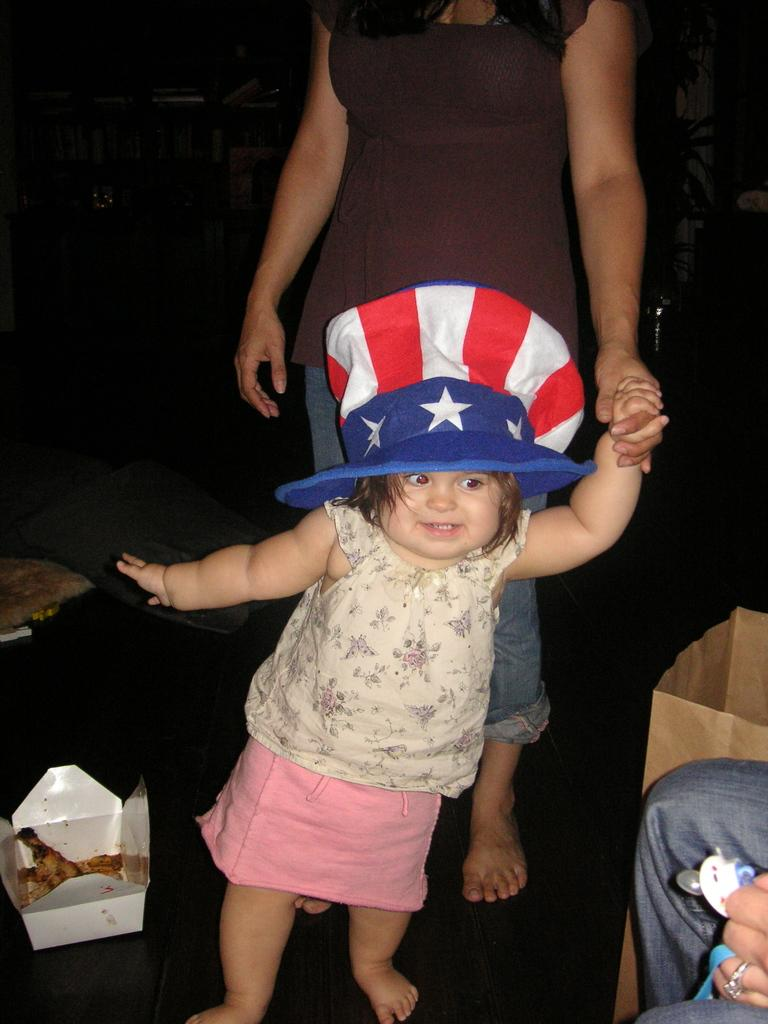Who is present in the image? There is a person and a kid in the image. What are the person and the kid doing in the image? Both the person and the kid are standing on the floor. Can you describe the person's attire? The person is wearing a cap. What other object can be seen in the image? There is a box in the image. How would you describe the lighting in the image? The background of the image is dark. What word does the kid say to express their comfort in the image? There is no indication of the kid's comfort or any spoken words in the image. How would you describe the taste of the box in the image? The box is an inanimate object and does not have a taste. 